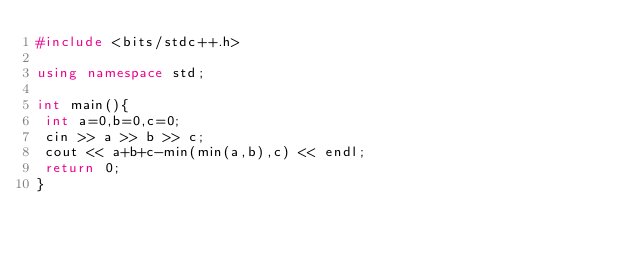<code> <loc_0><loc_0><loc_500><loc_500><_C++_>#include <bits/stdc++.h>

using namespace std;

int main(){
 int a=0,b=0,c=0;
 cin >> a >> b >> c;
 cout << a+b+c-min(min(a,b),c) << endl;
 return 0;
}</code> 